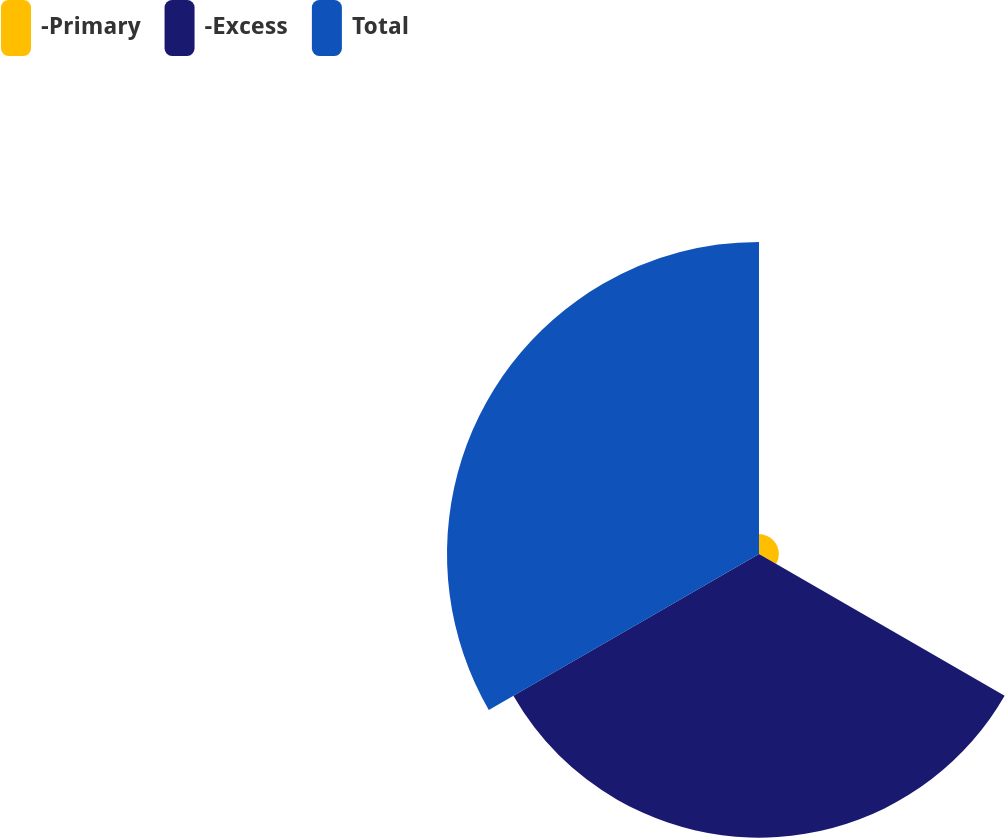Convert chart. <chart><loc_0><loc_0><loc_500><loc_500><pie_chart><fcel>-Primary<fcel>-Excess<fcel>Total<nl><fcel>3.23%<fcel>46.08%<fcel>50.69%<nl></chart> 